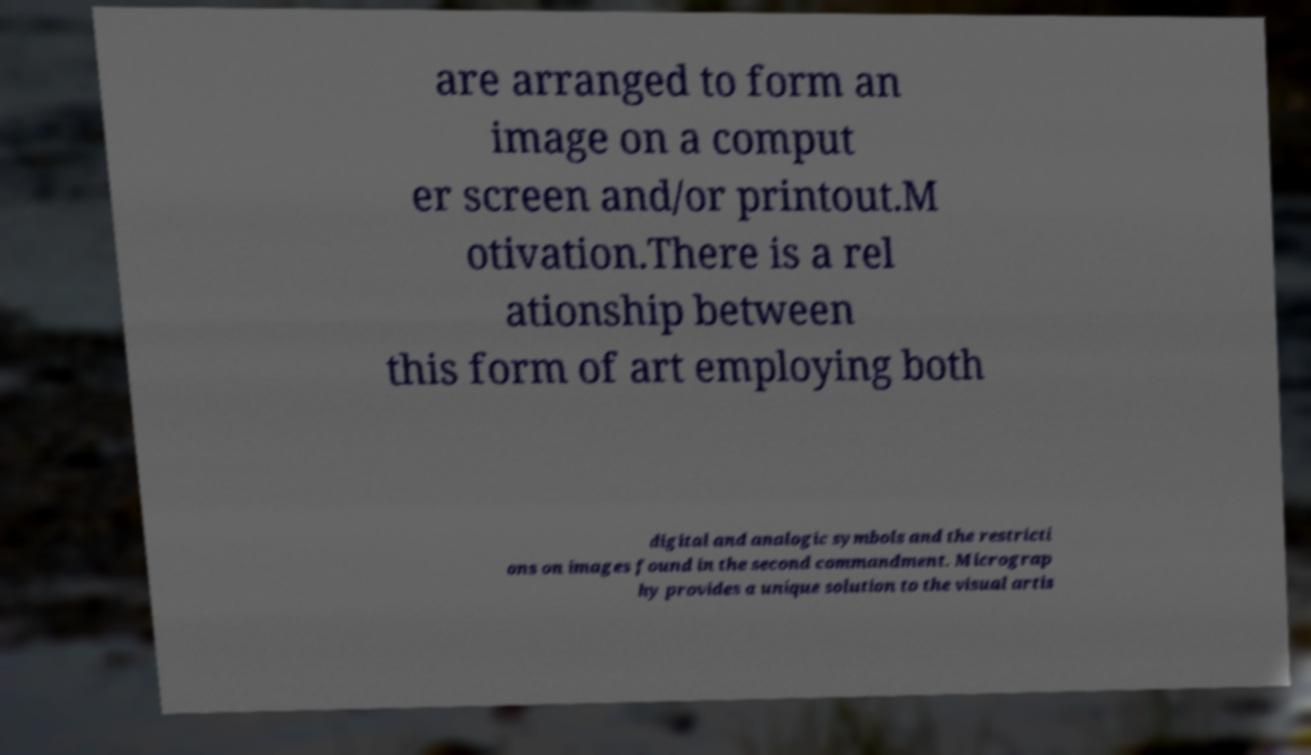Can you read and provide the text displayed in the image?This photo seems to have some interesting text. Can you extract and type it out for me? are arranged to form an image on a comput er screen and/or printout.M otivation.There is a rel ationship between this form of art employing both digital and analogic symbols and the restricti ons on images found in the second commandment. Micrograp hy provides a unique solution to the visual artis 